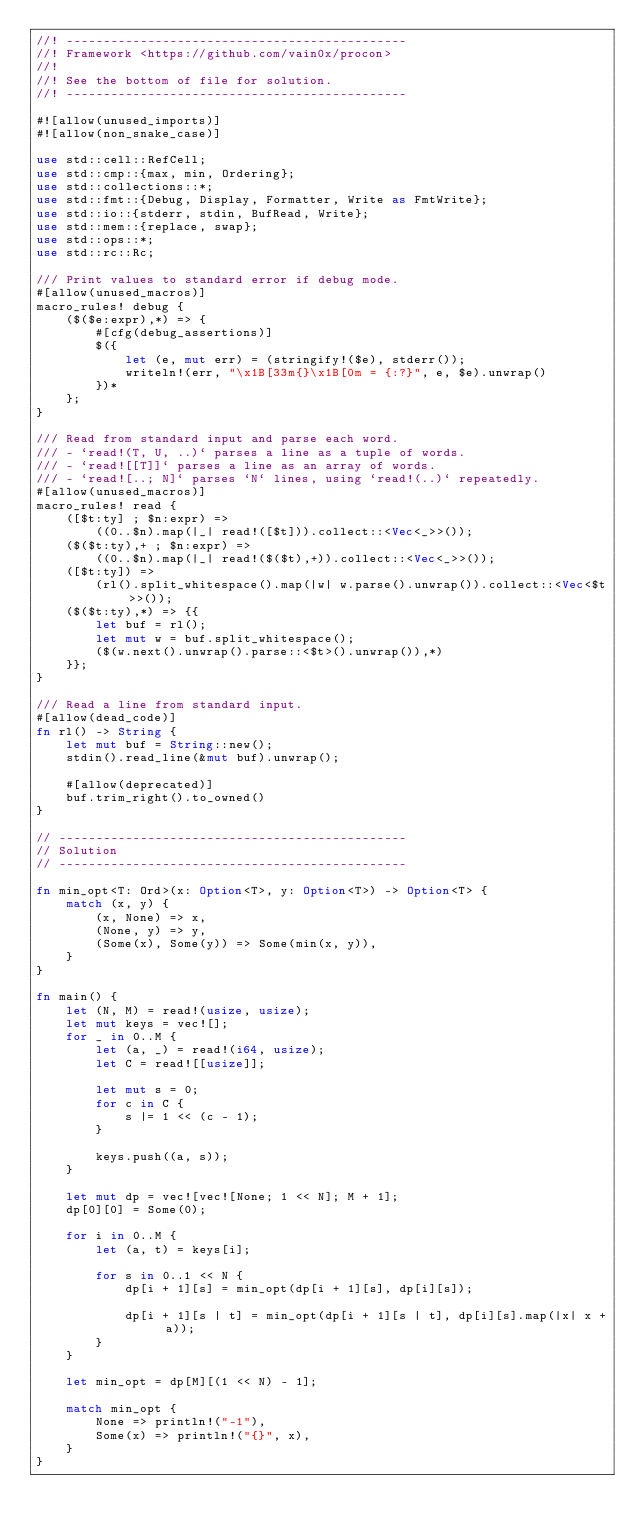Convert code to text. <code><loc_0><loc_0><loc_500><loc_500><_Rust_>//! ----------------------------------------------
//! Framework <https://github.com/vain0x/procon>
//!
//! See the bottom of file for solution.
//! ----------------------------------------------

#![allow(unused_imports)]
#![allow(non_snake_case)]

use std::cell::RefCell;
use std::cmp::{max, min, Ordering};
use std::collections::*;
use std::fmt::{Debug, Display, Formatter, Write as FmtWrite};
use std::io::{stderr, stdin, BufRead, Write};
use std::mem::{replace, swap};
use std::ops::*;
use std::rc::Rc;

/// Print values to standard error if debug mode.
#[allow(unused_macros)]
macro_rules! debug {
    ($($e:expr),*) => {
        #[cfg(debug_assertions)]
        $({
            let (e, mut err) = (stringify!($e), stderr());
            writeln!(err, "\x1B[33m{}\x1B[0m = {:?}", e, $e).unwrap()
        })*
    };
}

/// Read from standard input and parse each word.
/// - `read!(T, U, ..)` parses a line as a tuple of words.
/// - `read![[T]]` parses a line as an array of words.
/// - `read![..; N]` parses `N` lines, using `read!(..)` repeatedly.
#[allow(unused_macros)]
macro_rules! read {
    ([$t:ty] ; $n:expr) =>
        ((0..$n).map(|_| read!([$t])).collect::<Vec<_>>());
    ($($t:ty),+ ; $n:expr) =>
        ((0..$n).map(|_| read!($($t),+)).collect::<Vec<_>>());
    ([$t:ty]) =>
        (rl().split_whitespace().map(|w| w.parse().unwrap()).collect::<Vec<$t>>());
    ($($t:ty),*) => {{
        let buf = rl();
        let mut w = buf.split_whitespace();
        ($(w.next().unwrap().parse::<$t>().unwrap()),*)
    }};
}

/// Read a line from standard input.
#[allow(dead_code)]
fn rl() -> String {
    let mut buf = String::new();
    stdin().read_line(&mut buf).unwrap();

    #[allow(deprecated)]
    buf.trim_right().to_owned()
}

// -----------------------------------------------
// Solution
// -----------------------------------------------

fn min_opt<T: Ord>(x: Option<T>, y: Option<T>) -> Option<T> {
    match (x, y) {
        (x, None) => x,
        (None, y) => y,
        (Some(x), Some(y)) => Some(min(x, y)),
    }
}

fn main() {
    let (N, M) = read!(usize, usize);
    let mut keys = vec![];
    for _ in 0..M {
        let (a, _) = read!(i64, usize);
        let C = read![[usize]];

        let mut s = 0;
        for c in C {
            s |= 1 << (c - 1);
        }

        keys.push((a, s));
    }

    let mut dp = vec![vec![None; 1 << N]; M + 1];
    dp[0][0] = Some(0);

    for i in 0..M {
        let (a, t) = keys[i];

        for s in 0..1 << N {
            dp[i + 1][s] = min_opt(dp[i + 1][s], dp[i][s]);

            dp[i + 1][s | t] = min_opt(dp[i + 1][s | t], dp[i][s].map(|x| x + a));
        }
    }

    let min_opt = dp[M][(1 << N) - 1];

    match min_opt {
        None => println!("-1"),
        Some(x) => println!("{}", x),
    }
}
</code> 